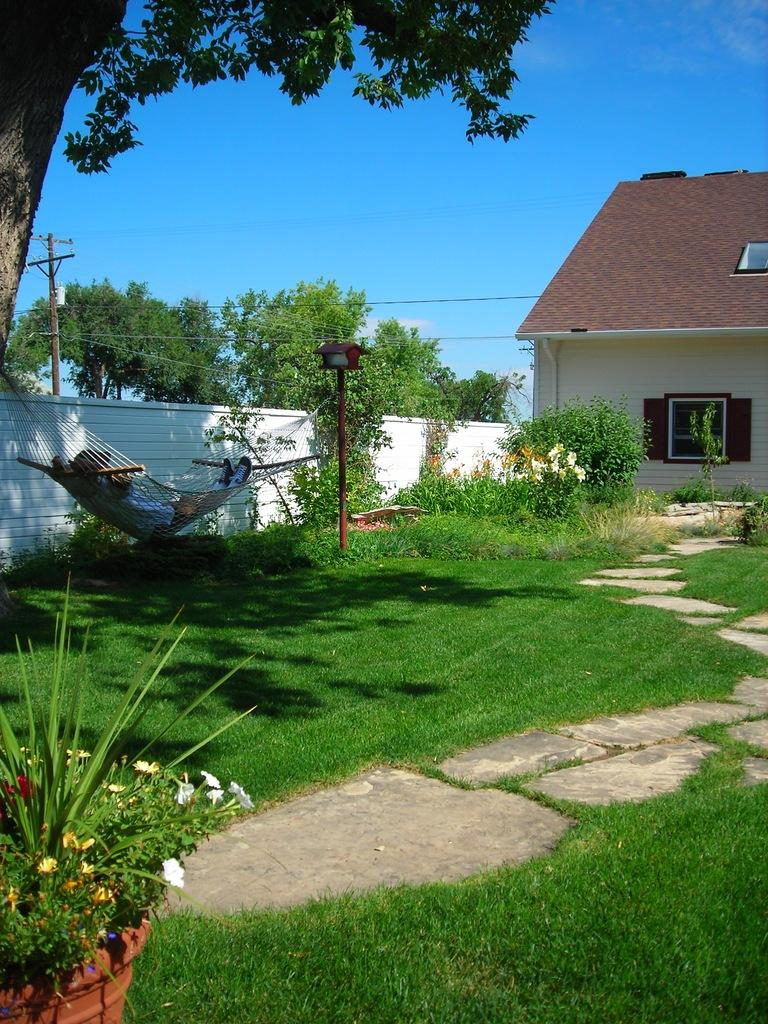What type of vegetation can be seen in the image? There are plants and trees in the image. Are there any man-made structures visible in the image? Yes, there is a building in the image. What is the condition of the sky in the image? The sky is clear in the image. What type of locket is hanging from the tree in the image? There is no locket present in the image; it features plants, trees, a building, and a clear sky. Is there any coal visible in the image? There is no coal present in the image. 